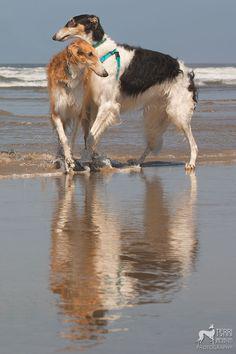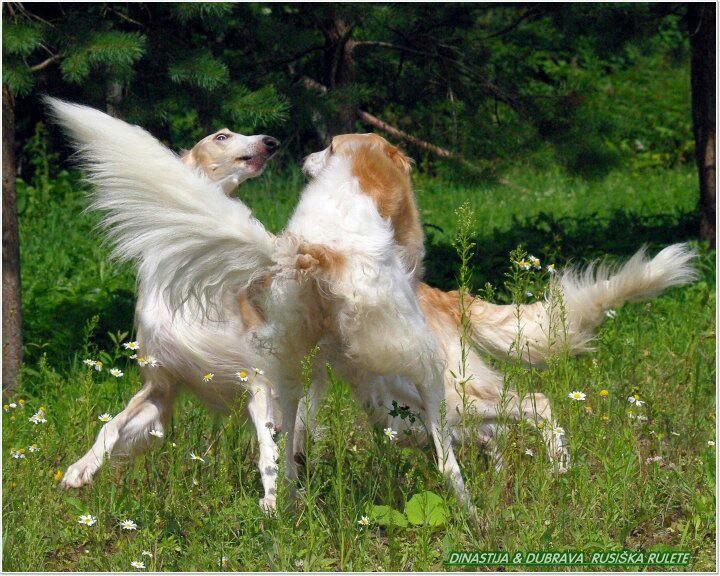The first image is the image on the left, the second image is the image on the right. For the images displayed, is the sentence "Two dogs are running together in a field of grass." factually correct? Answer yes or no. Yes. The first image is the image on the left, the second image is the image on the right. Assess this claim about the two images: "An image shows two hounds with faces turned inward, toward each other, and one with its head above the other.". Correct or not? Answer yes or no. Yes. 